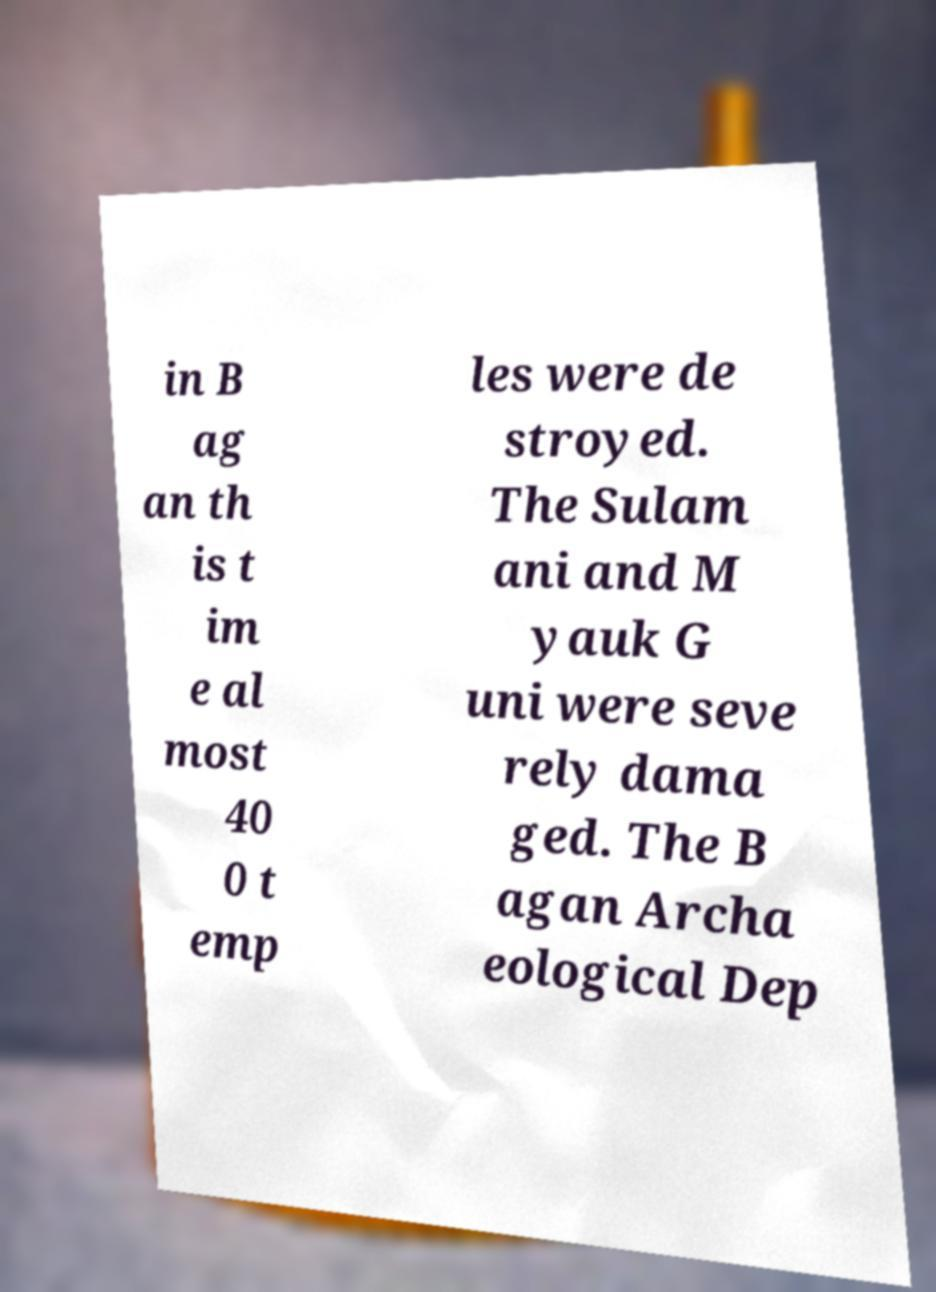Please identify and transcribe the text found in this image. in B ag an th is t im e al most 40 0 t emp les were de stroyed. The Sulam ani and M yauk G uni were seve rely dama ged. The B agan Archa eological Dep 